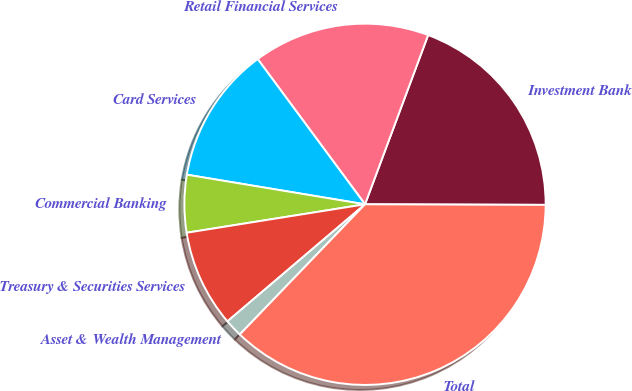Convert chart to OTSL. <chart><loc_0><loc_0><loc_500><loc_500><pie_chart><fcel>Investment Bank<fcel>Retail Financial Services<fcel>Card Services<fcel>Commercial Banking<fcel>Treasury & Securities Services<fcel>Asset & Wealth Management<fcel>Total<nl><fcel>19.37%<fcel>15.81%<fcel>12.25%<fcel>5.14%<fcel>8.7%<fcel>1.59%<fcel>37.14%<nl></chart> 